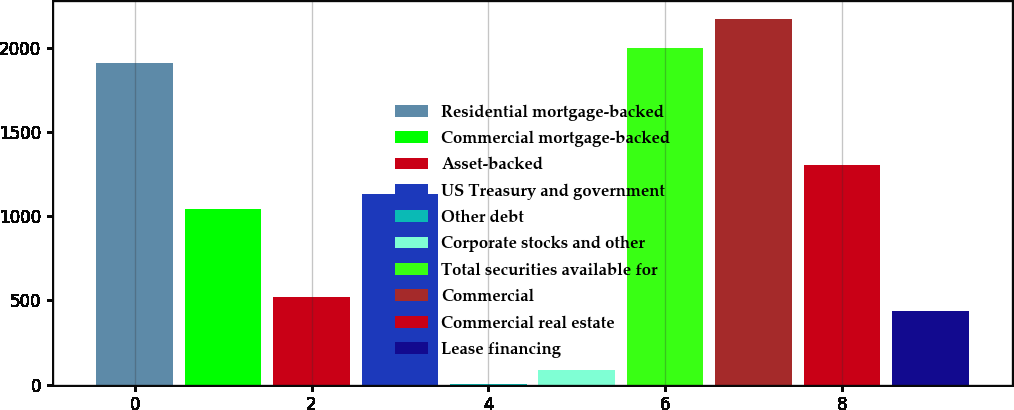Convert chart. <chart><loc_0><loc_0><loc_500><loc_500><bar_chart><fcel>Residential mortgage-backed<fcel>Commercial mortgage-backed<fcel>Asset-backed<fcel>US Treasury and government<fcel>Other debt<fcel>Corporate stocks and other<fcel>Total securities available for<fcel>Commercial<fcel>Commercial real estate<fcel>Lease financing<nl><fcel>1911.6<fcel>1043.6<fcel>522.8<fcel>1130.4<fcel>2<fcel>88.8<fcel>1998.4<fcel>2172<fcel>1304<fcel>436<nl></chart> 